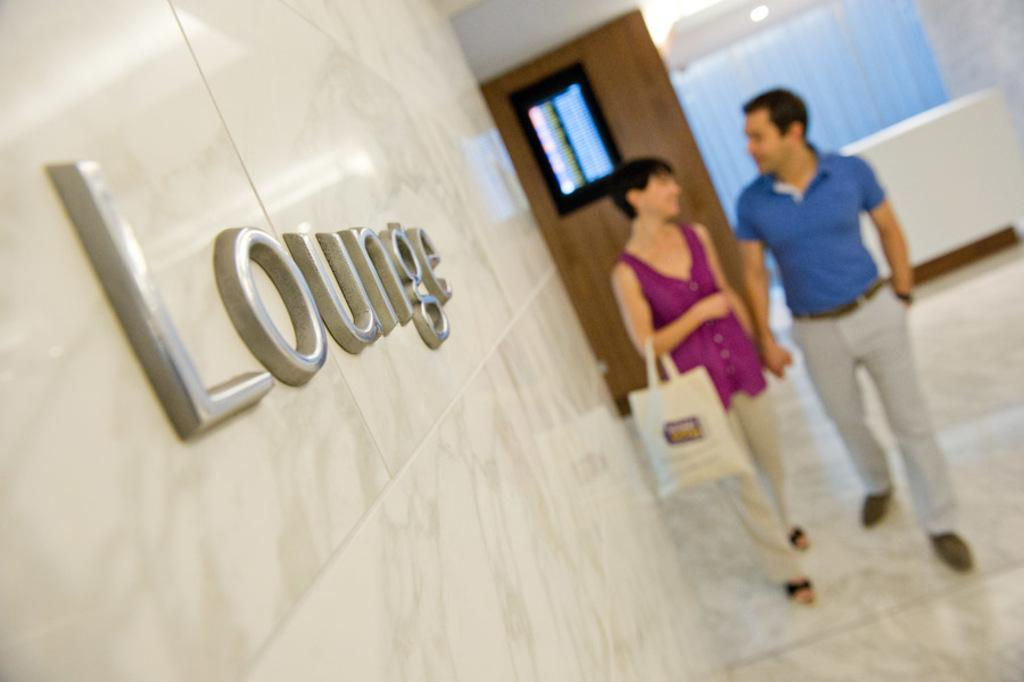What is written or displayed on the wall in the image? There are letters on the wall in the image. How many people are present in the image? There are two persons standing in the image. Can you describe the person with a bag in the image? There is a person with a bag in the image. What can be used to provide illumination in the image? There is a light in the image. What is a piece of furniture that can be seen in the image? There is a table in the image. What type of window treatment is present in the image? There is a curtain in the image. What type of machine is being operated by the person with the bag in the image? There is no machine present in the image; it only shows two persons standing, one with a bag, and other elements like letters, light, table, and curtain. How many pages are visible in the image? There are no pages present in the image. 